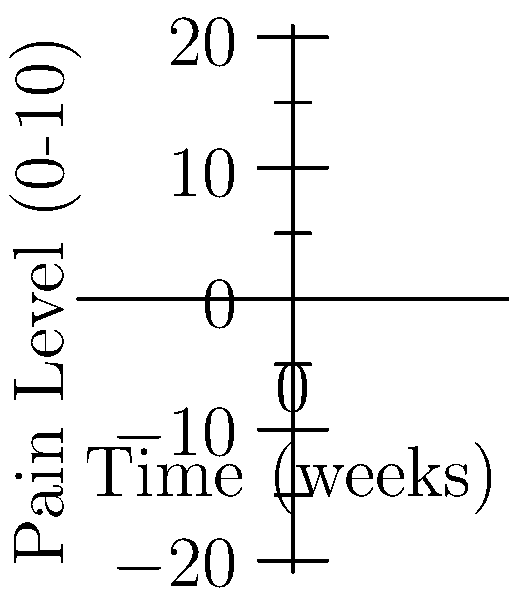The graph shows your pain levels over 6 weeks of recovery after a sports injury, with chiropractic adjustments starting at week 0. If this trend continues linearly, in how many weeks from the start will your pain level reach 0? To solve this problem, we need to follow these steps:

1. Identify the starting and ending points of the line:
   Point A: (0, 8) - Week 0, Pain level 8
   Point B: (6, 1) - Week 6, Pain level 1

2. Calculate the slope of the line:
   Slope = $\frac{y_2 - y_1}{x_2 - x_1} = \frac{1 - 8}{6 - 0} = \frac{-7}{6} \approx -1.167$

3. Use the point-slope form of a line to find the equation:
   $y - y_1 = m(x - x_1)$
   $y - 8 = -\frac{7}{6}(x - 0)$
   $y = -\frac{7}{6}x + 8$

4. To find when the pain level reaches 0, set $y = 0$ and solve for $x$:
   $0 = -\frac{7}{6}x + 8$
   $\frac{7}{6}x = 8$
   $x = \frac{48}{7} \approx 6.86$

Therefore, if the trend continues linearly, the pain level will reach 0 after approximately 6.86 weeks from the start.
Answer: 7 weeks 